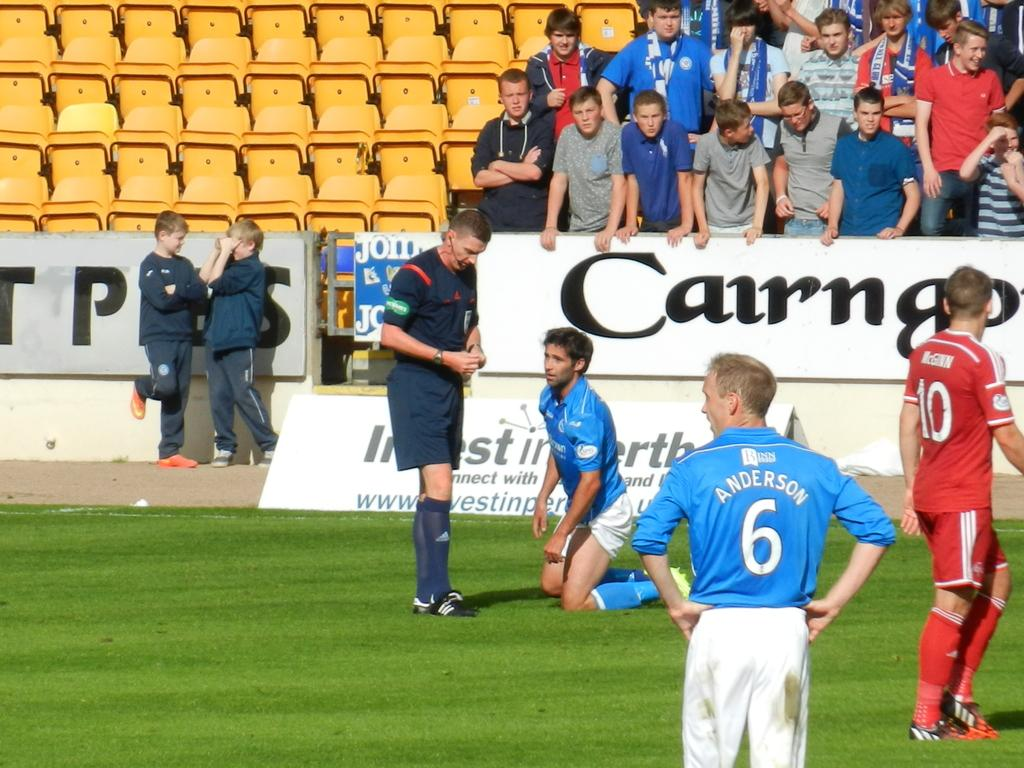<image>
Create a compact narrative representing the image presented. A soccer player kneeling and another one wearing a blue shirt that says Anderson on the back. 